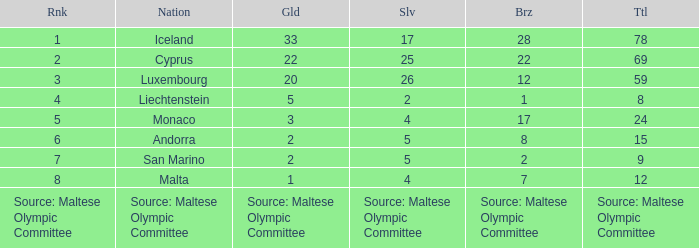What is the number of gold medals when the number of bronze medals is 8? 2.0. 